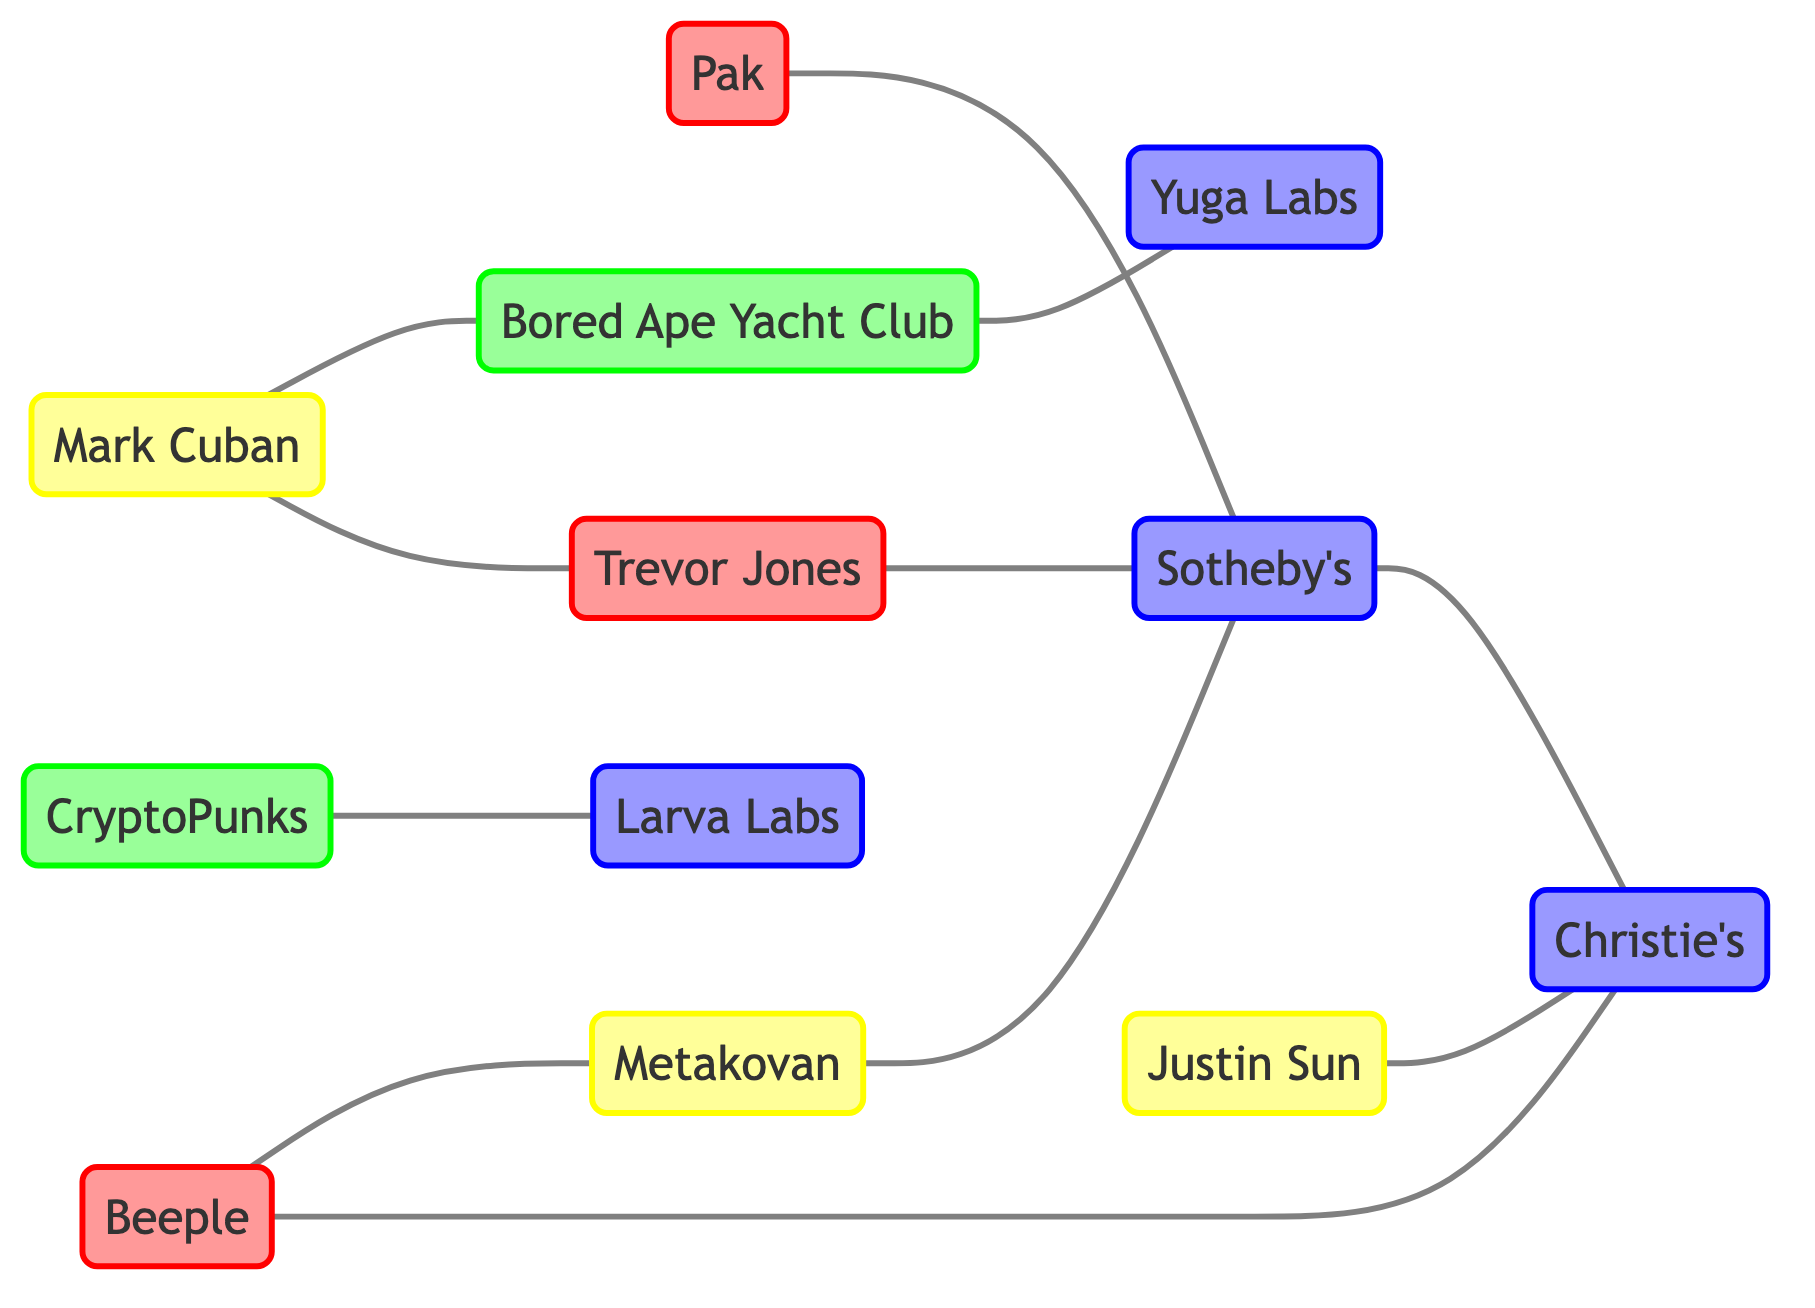What is the total number of nodes in the graph? To find the total number of nodes, we count each distinct individual, collection, or company listed in the nodes section of the data. Here, there are 12 different nodes in total.
Answer: 12 Who is connected to Sotheby's? In the graph, we can look for all nodes that have edges linking to Sotheby's. The connections are from Pak, Trevor Jones, Metakovan, and Christie's. Therefore, there are multiple connections to Sotheby's.
Answer: Pak, Trevor Jones, Metakovan, Christie's How many edges are in the graph? The edges are represented by the links between the nodes. By counting each link in the links section of the data, we find there are 11 edges connecting various nodes.
Answer: 11 Which two artists are connected to Christie's? To answer this, we examine all the links connected to Christie's. The nodes that connect to Christie's include Beeple and Justin Sun. Thus, both of these individuals are connected to the auction house.
Answer: Beeple, Justin Sun How many distinct collections are represented in the graph? We identify collections by looking at the nodes classified with the label "collection." In this diagram, CryptoPunks and Bored Ape Yacht Club are listed as collections, making a total of 2 distinct collections.
Answer: 2 Which individual is linked to both Bored Ape Yacht Club and Trevor Jones? We need to check the connections of both nodes. Mark Cuban is connected to Bored Ape Yacht Club and also has a direct edge to Trevor Jones. Thus, he is the individual connected to both.
Answer: Mark Cuban Which company connects both Sotheby's and Christie's? We explore the links that connect these two companies. Sotheby's has a direct edge to Christie's, meaning they are connected without needing any other intermediary company.
Answer: Sotheby's Which collection is associated with Larva Labs? To answer this, we look at the edges linked from Larva Labs and check if they connect to any other nodes. Here, Larva Labs is linked to CryptoPunks. Thus, CryptoPunks is the collection associated with Larva Labs.
Answer: CryptoPunks What is the relationship between Metakovan and Sotheby's? By looking at the links, we find that Metakovan has a direct connection with Sotheby's. This indicates that they are directly related in the context of the graph.
Answer: Direct connection 